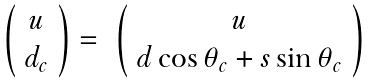<formula> <loc_0><loc_0><loc_500><loc_500>\begin{array} { c c c } \left ( \begin{array} { c } u \\ d _ { c } \end{array} \right ) = & \left ( \begin{array} { c } u \\ d \cos \theta _ { c } + s \sin \theta _ { c } \end{array} \right ) \end{array}</formula> 